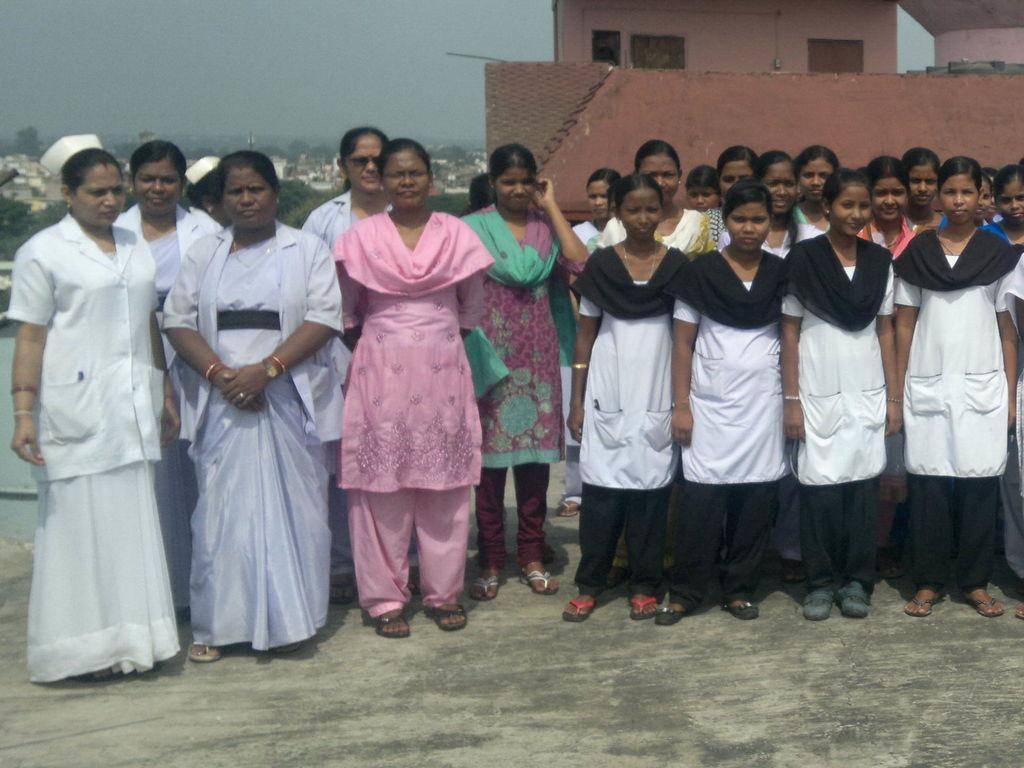What is happening in the foreground of the image? There are persons standing on a floor in the image. What can be seen in the distance behind the persons? There are buildings and trees in the background of the image. What is visible at the top of the image? The sky is visible at the top of the image. Are there any chairs visible in the image? There is no mention of chairs in the provided facts, so we cannot determine if any are present in the image. Can you tell me how many basins are being used by the persons in the image? There is no mention of basins in the provided facts, so we cannot determine if any are present in the image. 